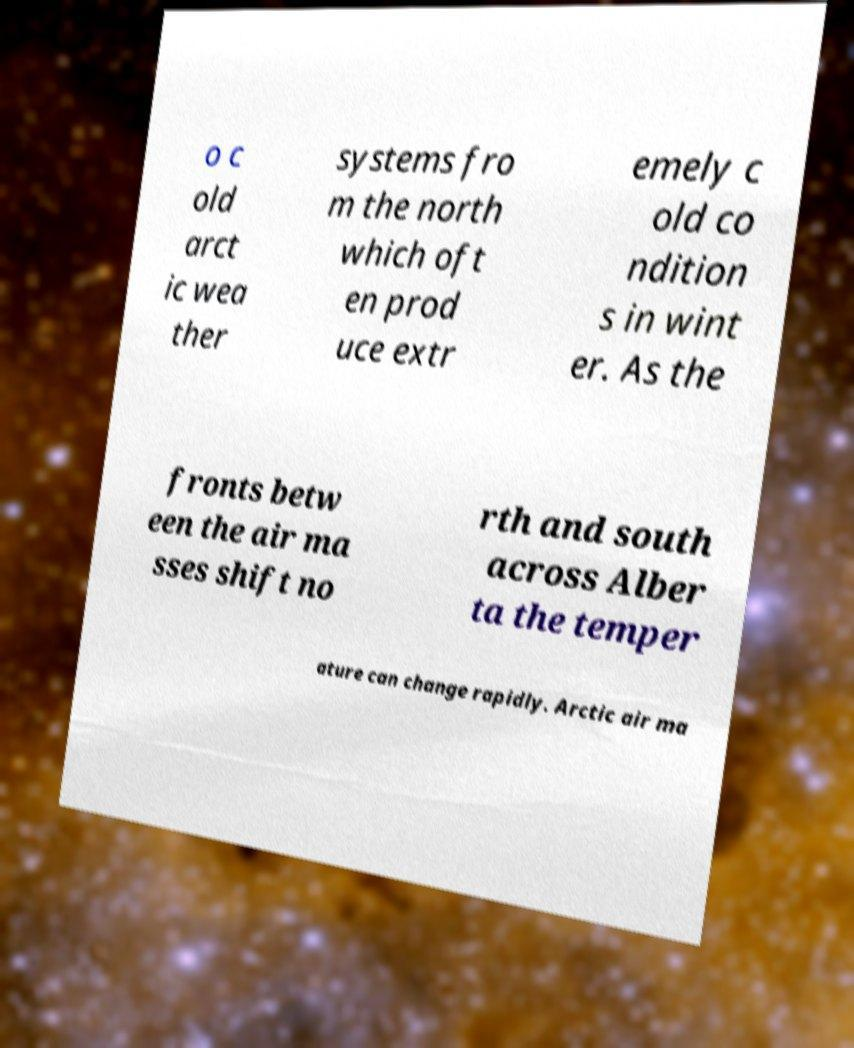Can you accurately transcribe the text from the provided image for me? o c old arct ic wea ther systems fro m the north which oft en prod uce extr emely c old co ndition s in wint er. As the fronts betw een the air ma sses shift no rth and south across Alber ta the temper ature can change rapidly. Arctic air ma 